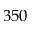Convert formula to latex. <formula><loc_0><loc_0><loc_500><loc_500>3 5 0</formula> 